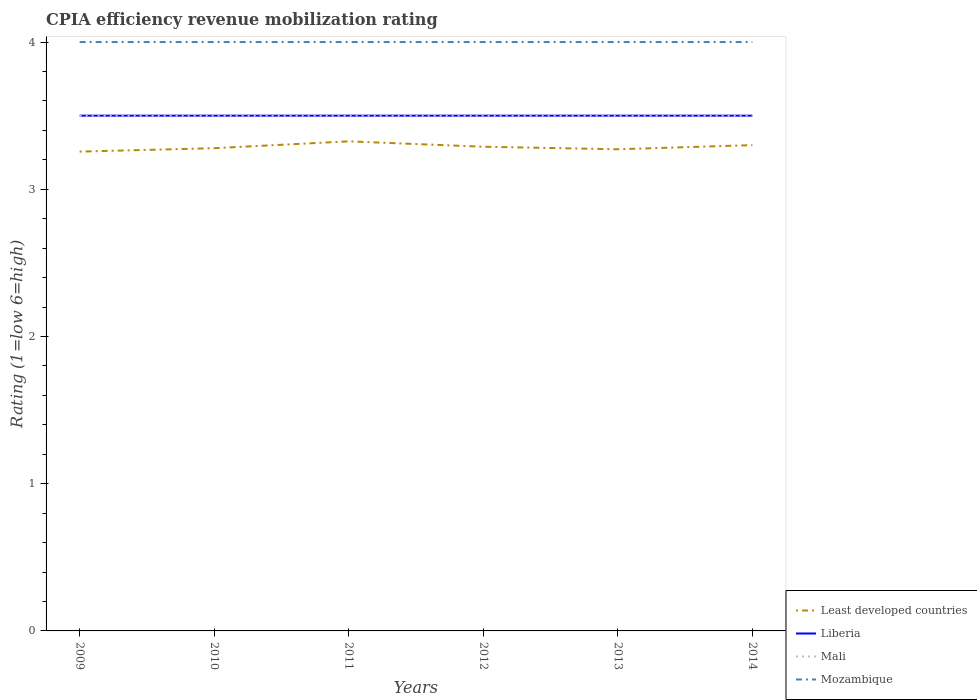In which year was the CPIA rating in Liberia maximum?
Make the answer very short. 2009. What is the total CPIA rating in Least developed countries in the graph?
Provide a succinct answer. -0.02. What is the difference between the highest and the lowest CPIA rating in Liberia?
Your answer should be very brief. 0. How many lines are there?
Provide a succinct answer. 4. Does the graph contain grids?
Provide a succinct answer. No. How many legend labels are there?
Provide a succinct answer. 4. What is the title of the graph?
Provide a short and direct response. CPIA efficiency revenue mobilization rating. Does "Denmark" appear as one of the legend labels in the graph?
Your answer should be very brief. No. What is the label or title of the X-axis?
Make the answer very short. Years. What is the Rating (1=low 6=high) of Least developed countries in 2009?
Provide a short and direct response. 3.26. What is the Rating (1=low 6=high) of Liberia in 2009?
Offer a terse response. 3.5. What is the Rating (1=low 6=high) of Mali in 2009?
Your answer should be compact. 3.5. What is the Rating (1=low 6=high) of Least developed countries in 2010?
Ensure brevity in your answer.  3.28. What is the Rating (1=low 6=high) in Liberia in 2010?
Provide a succinct answer. 3.5. What is the Rating (1=low 6=high) of Mozambique in 2010?
Your answer should be compact. 4. What is the Rating (1=low 6=high) of Least developed countries in 2011?
Make the answer very short. 3.33. What is the Rating (1=low 6=high) of Mali in 2011?
Make the answer very short. 3.5. What is the Rating (1=low 6=high) in Mozambique in 2011?
Offer a terse response. 4. What is the Rating (1=low 6=high) of Least developed countries in 2012?
Give a very brief answer. 3.29. What is the Rating (1=low 6=high) in Liberia in 2012?
Keep it short and to the point. 3.5. What is the Rating (1=low 6=high) of Least developed countries in 2013?
Your answer should be compact. 3.27. What is the Rating (1=low 6=high) in Liberia in 2013?
Keep it short and to the point. 3.5. What is the Rating (1=low 6=high) of Mali in 2013?
Make the answer very short. 3.5. What is the Rating (1=low 6=high) of Liberia in 2014?
Offer a terse response. 3.5. Across all years, what is the maximum Rating (1=low 6=high) in Least developed countries?
Ensure brevity in your answer.  3.33. Across all years, what is the minimum Rating (1=low 6=high) in Least developed countries?
Give a very brief answer. 3.26. Across all years, what is the minimum Rating (1=low 6=high) in Liberia?
Offer a very short reply. 3.5. Across all years, what is the minimum Rating (1=low 6=high) of Mozambique?
Provide a succinct answer. 4. What is the total Rating (1=low 6=high) of Least developed countries in the graph?
Offer a very short reply. 19.72. What is the total Rating (1=low 6=high) of Liberia in the graph?
Your answer should be compact. 21. What is the total Rating (1=low 6=high) of Mali in the graph?
Provide a short and direct response. 21. What is the difference between the Rating (1=low 6=high) of Least developed countries in 2009 and that in 2010?
Provide a succinct answer. -0.02. What is the difference between the Rating (1=low 6=high) in Mozambique in 2009 and that in 2010?
Ensure brevity in your answer.  0. What is the difference between the Rating (1=low 6=high) of Least developed countries in 2009 and that in 2011?
Ensure brevity in your answer.  -0.07. What is the difference between the Rating (1=low 6=high) of Least developed countries in 2009 and that in 2012?
Give a very brief answer. -0.03. What is the difference between the Rating (1=low 6=high) of Liberia in 2009 and that in 2012?
Ensure brevity in your answer.  0. What is the difference between the Rating (1=low 6=high) of Mozambique in 2009 and that in 2012?
Your answer should be very brief. 0. What is the difference between the Rating (1=low 6=high) in Least developed countries in 2009 and that in 2013?
Your answer should be compact. -0.02. What is the difference between the Rating (1=low 6=high) in Least developed countries in 2009 and that in 2014?
Make the answer very short. -0.04. What is the difference between the Rating (1=low 6=high) of Mali in 2009 and that in 2014?
Make the answer very short. 0. What is the difference between the Rating (1=low 6=high) of Mozambique in 2009 and that in 2014?
Give a very brief answer. 0. What is the difference between the Rating (1=low 6=high) of Least developed countries in 2010 and that in 2011?
Your answer should be very brief. -0.05. What is the difference between the Rating (1=low 6=high) of Liberia in 2010 and that in 2011?
Make the answer very short. 0. What is the difference between the Rating (1=low 6=high) in Least developed countries in 2010 and that in 2012?
Give a very brief answer. -0.01. What is the difference between the Rating (1=low 6=high) in Mozambique in 2010 and that in 2012?
Provide a succinct answer. 0. What is the difference between the Rating (1=low 6=high) in Least developed countries in 2010 and that in 2013?
Your response must be concise. 0.01. What is the difference between the Rating (1=low 6=high) of Liberia in 2010 and that in 2013?
Make the answer very short. 0. What is the difference between the Rating (1=low 6=high) in Mali in 2010 and that in 2013?
Keep it short and to the point. 0. What is the difference between the Rating (1=low 6=high) of Least developed countries in 2010 and that in 2014?
Offer a terse response. -0.02. What is the difference between the Rating (1=low 6=high) of Liberia in 2010 and that in 2014?
Your response must be concise. 0. What is the difference between the Rating (1=low 6=high) in Least developed countries in 2011 and that in 2012?
Provide a succinct answer. 0.04. What is the difference between the Rating (1=low 6=high) of Liberia in 2011 and that in 2012?
Make the answer very short. 0. What is the difference between the Rating (1=low 6=high) of Mali in 2011 and that in 2012?
Provide a short and direct response. 0. What is the difference between the Rating (1=low 6=high) in Least developed countries in 2011 and that in 2013?
Keep it short and to the point. 0.05. What is the difference between the Rating (1=low 6=high) in Mali in 2011 and that in 2013?
Your response must be concise. 0. What is the difference between the Rating (1=low 6=high) of Least developed countries in 2011 and that in 2014?
Provide a succinct answer. 0.03. What is the difference between the Rating (1=low 6=high) of Liberia in 2011 and that in 2014?
Ensure brevity in your answer.  0. What is the difference between the Rating (1=low 6=high) in Mozambique in 2011 and that in 2014?
Keep it short and to the point. 0. What is the difference between the Rating (1=low 6=high) of Least developed countries in 2012 and that in 2013?
Your response must be concise. 0.02. What is the difference between the Rating (1=low 6=high) of Liberia in 2012 and that in 2013?
Your answer should be compact. 0. What is the difference between the Rating (1=low 6=high) of Mali in 2012 and that in 2013?
Ensure brevity in your answer.  0. What is the difference between the Rating (1=low 6=high) of Least developed countries in 2012 and that in 2014?
Your answer should be compact. -0.01. What is the difference between the Rating (1=low 6=high) of Liberia in 2012 and that in 2014?
Your response must be concise. 0. What is the difference between the Rating (1=low 6=high) in Mali in 2012 and that in 2014?
Offer a terse response. 0. What is the difference between the Rating (1=low 6=high) in Mozambique in 2012 and that in 2014?
Offer a terse response. 0. What is the difference between the Rating (1=low 6=high) in Least developed countries in 2013 and that in 2014?
Your response must be concise. -0.03. What is the difference between the Rating (1=low 6=high) of Mali in 2013 and that in 2014?
Your answer should be very brief. 0. What is the difference between the Rating (1=low 6=high) of Least developed countries in 2009 and the Rating (1=low 6=high) of Liberia in 2010?
Offer a very short reply. -0.24. What is the difference between the Rating (1=low 6=high) of Least developed countries in 2009 and the Rating (1=low 6=high) of Mali in 2010?
Offer a terse response. -0.24. What is the difference between the Rating (1=low 6=high) of Least developed countries in 2009 and the Rating (1=low 6=high) of Mozambique in 2010?
Offer a terse response. -0.74. What is the difference between the Rating (1=low 6=high) in Least developed countries in 2009 and the Rating (1=low 6=high) in Liberia in 2011?
Give a very brief answer. -0.24. What is the difference between the Rating (1=low 6=high) of Least developed countries in 2009 and the Rating (1=low 6=high) of Mali in 2011?
Keep it short and to the point. -0.24. What is the difference between the Rating (1=low 6=high) in Least developed countries in 2009 and the Rating (1=low 6=high) in Mozambique in 2011?
Provide a succinct answer. -0.74. What is the difference between the Rating (1=low 6=high) in Liberia in 2009 and the Rating (1=low 6=high) in Mali in 2011?
Provide a succinct answer. 0. What is the difference between the Rating (1=low 6=high) of Liberia in 2009 and the Rating (1=low 6=high) of Mozambique in 2011?
Make the answer very short. -0.5. What is the difference between the Rating (1=low 6=high) of Least developed countries in 2009 and the Rating (1=low 6=high) of Liberia in 2012?
Your response must be concise. -0.24. What is the difference between the Rating (1=low 6=high) of Least developed countries in 2009 and the Rating (1=low 6=high) of Mali in 2012?
Keep it short and to the point. -0.24. What is the difference between the Rating (1=low 6=high) in Least developed countries in 2009 and the Rating (1=low 6=high) in Mozambique in 2012?
Give a very brief answer. -0.74. What is the difference between the Rating (1=low 6=high) in Liberia in 2009 and the Rating (1=low 6=high) in Mali in 2012?
Your response must be concise. 0. What is the difference between the Rating (1=low 6=high) in Mali in 2009 and the Rating (1=low 6=high) in Mozambique in 2012?
Your answer should be compact. -0.5. What is the difference between the Rating (1=low 6=high) of Least developed countries in 2009 and the Rating (1=low 6=high) of Liberia in 2013?
Ensure brevity in your answer.  -0.24. What is the difference between the Rating (1=low 6=high) of Least developed countries in 2009 and the Rating (1=low 6=high) of Mali in 2013?
Offer a terse response. -0.24. What is the difference between the Rating (1=low 6=high) in Least developed countries in 2009 and the Rating (1=low 6=high) in Mozambique in 2013?
Make the answer very short. -0.74. What is the difference between the Rating (1=low 6=high) in Liberia in 2009 and the Rating (1=low 6=high) in Mozambique in 2013?
Provide a succinct answer. -0.5. What is the difference between the Rating (1=low 6=high) in Least developed countries in 2009 and the Rating (1=low 6=high) in Liberia in 2014?
Offer a very short reply. -0.24. What is the difference between the Rating (1=low 6=high) in Least developed countries in 2009 and the Rating (1=low 6=high) in Mali in 2014?
Ensure brevity in your answer.  -0.24. What is the difference between the Rating (1=low 6=high) in Least developed countries in 2009 and the Rating (1=low 6=high) in Mozambique in 2014?
Ensure brevity in your answer.  -0.74. What is the difference between the Rating (1=low 6=high) of Liberia in 2009 and the Rating (1=low 6=high) of Mozambique in 2014?
Provide a succinct answer. -0.5. What is the difference between the Rating (1=low 6=high) of Least developed countries in 2010 and the Rating (1=low 6=high) of Liberia in 2011?
Your answer should be very brief. -0.22. What is the difference between the Rating (1=low 6=high) of Least developed countries in 2010 and the Rating (1=low 6=high) of Mali in 2011?
Keep it short and to the point. -0.22. What is the difference between the Rating (1=low 6=high) of Least developed countries in 2010 and the Rating (1=low 6=high) of Mozambique in 2011?
Provide a succinct answer. -0.72. What is the difference between the Rating (1=low 6=high) in Liberia in 2010 and the Rating (1=low 6=high) in Mali in 2011?
Provide a short and direct response. 0. What is the difference between the Rating (1=low 6=high) in Least developed countries in 2010 and the Rating (1=low 6=high) in Liberia in 2012?
Ensure brevity in your answer.  -0.22. What is the difference between the Rating (1=low 6=high) of Least developed countries in 2010 and the Rating (1=low 6=high) of Mali in 2012?
Make the answer very short. -0.22. What is the difference between the Rating (1=low 6=high) in Least developed countries in 2010 and the Rating (1=low 6=high) in Mozambique in 2012?
Offer a very short reply. -0.72. What is the difference between the Rating (1=low 6=high) of Liberia in 2010 and the Rating (1=low 6=high) of Mali in 2012?
Your response must be concise. 0. What is the difference between the Rating (1=low 6=high) in Liberia in 2010 and the Rating (1=low 6=high) in Mozambique in 2012?
Make the answer very short. -0.5. What is the difference between the Rating (1=low 6=high) in Least developed countries in 2010 and the Rating (1=low 6=high) in Liberia in 2013?
Your response must be concise. -0.22. What is the difference between the Rating (1=low 6=high) of Least developed countries in 2010 and the Rating (1=low 6=high) of Mali in 2013?
Keep it short and to the point. -0.22. What is the difference between the Rating (1=low 6=high) of Least developed countries in 2010 and the Rating (1=low 6=high) of Mozambique in 2013?
Offer a very short reply. -0.72. What is the difference between the Rating (1=low 6=high) of Liberia in 2010 and the Rating (1=low 6=high) of Mozambique in 2013?
Your response must be concise. -0.5. What is the difference between the Rating (1=low 6=high) in Mali in 2010 and the Rating (1=low 6=high) in Mozambique in 2013?
Provide a succinct answer. -0.5. What is the difference between the Rating (1=low 6=high) of Least developed countries in 2010 and the Rating (1=low 6=high) of Liberia in 2014?
Provide a succinct answer. -0.22. What is the difference between the Rating (1=low 6=high) in Least developed countries in 2010 and the Rating (1=low 6=high) in Mali in 2014?
Offer a terse response. -0.22. What is the difference between the Rating (1=low 6=high) of Least developed countries in 2010 and the Rating (1=low 6=high) of Mozambique in 2014?
Offer a terse response. -0.72. What is the difference between the Rating (1=low 6=high) of Liberia in 2010 and the Rating (1=low 6=high) of Mali in 2014?
Give a very brief answer. 0. What is the difference between the Rating (1=low 6=high) of Mali in 2010 and the Rating (1=low 6=high) of Mozambique in 2014?
Provide a succinct answer. -0.5. What is the difference between the Rating (1=low 6=high) of Least developed countries in 2011 and the Rating (1=low 6=high) of Liberia in 2012?
Your answer should be compact. -0.17. What is the difference between the Rating (1=low 6=high) in Least developed countries in 2011 and the Rating (1=low 6=high) in Mali in 2012?
Provide a succinct answer. -0.17. What is the difference between the Rating (1=low 6=high) of Least developed countries in 2011 and the Rating (1=low 6=high) of Mozambique in 2012?
Make the answer very short. -0.67. What is the difference between the Rating (1=low 6=high) of Liberia in 2011 and the Rating (1=low 6=high) of Mali in 2012?
Ensure brevity in your answer.  0. What is the difference between the Rating (1=low 6=high) in Least developed countries in 2011 and the Rating (1=low 6=high) in Liberia in 2013?
Your response must be concise. -0.17. What is the difference between the Rating (1=low 6=high) of Least developed countries in 2011 and the Rating (1=low 6=high) of Mali in 2013?
Provide a succinct answer. -0.17. What is the difference between the Rating (1=low 6=high) in Least developed countries in 2011 and the Rating (1=low 6=high) in Mozambique in 2013?
Ensure brevity in your answer.  -0.67. What is the difference between the Rating (1=low 6=high) in Liberia in 2011 and the Rating (1=low 6=high) in Mozambique in 2013?
Provide a succinct answer. -0.5. What is the difference between the Rating (1=low 6=high) in Mali in 2011 and the Rating (1=low 6=high) in Mozambique in 2013?
Provide a succinct answer. -0.5. What is the difference between the Rating (1=low 6=high) in Least developed countries in 2011 and the Rating (1=low 6=high) in Liberia in 2014?
Provide a succinct answer. -0.17. What is the difference between the Rating (1=low 6=high) of Least developed countries in 2011 and the Rating (1=low 6=high) of Mali in 2014?
Provide a short and direct response. -0.17. What is the difference between the Rating (1=low 6=high) of Least developed countries in 2011 and the Rating (1=low 6=high) of Mozambique in 2014?
Give a very brief answer. -0.67. What is the difference between the Rating (1=low 6=high) of Least developed countries in 2012 and the Rating (1=low 6=high) of Liberia in 2013?
Give a very brief answer. -0.21. What is the difference between the Rating (1=low 6=high) of Least developed countries in 2012 and the Rating (1=low 6=high) of Mali in 2013?
Provide a succinct answer. -0.21. What is the difference between the Rating (1=low 6=high) of Least developed countries in 2012 and the Rating (1=low 6=high) of Mozambique in 2013?
Provide a short and direct response. -0.71. What is the difference between the Rating (1=low 6=high) in Liberia in 2012 and the Rating (1=low 6=high) in Mozambique in 2013?
Your response must be concise. -0.5. What is the difference between the Rating (1=low 6=high) of Mali in 2012 and the Rating (1=low 6=high) of Mozambique in 2013?
Give a very brief answer. -0.5. What is the difference between the Rating (1=low 6=high) in Least developed countries in 2012 and the Rating (1=low 6=high) in Liberia in 2014?
Your answer should be compact. -0.21. What is the difference between the Rating (1=low 6=high) of Least developed countries in 2012 and the Rating (1=low 6=high) of Mali in 2014?
Ensure brevity in your answer.  -0.21. What is the difference between the Rating (1=low 6=high) in Least developed countries in 2012 and the Rating (1=low 6=high) in Mozambique in 2014?
Your answer should be very brief. -0.71. What is the difference between the Rating (1=low 6=high) in Liberia in 2012 and the Rating (1=low 6=high) in Mali in 2014?
Provide a succinct answer. 0. What is the difference between the Rating (1=low 6=high) in Mali in 2012 and the Rating (1=low 6=high) in Mozambique in 2014?
Keep it short and to the point. -0.5. What is the difference between the Rating (1=low 6=high) of Least developed countries in 2013 and the Rating (1=low 6=high) of Liberia in 2014?
Provide a succinct answer. -0.23. What is the difference between the Rating (1=low 6=high) of Least developed countries in 2013 and the Rating (1=low 6=high) of Mali in 2014?
Offer a very short reply. -0.23. What is the difference between the Rating (1=low 6=high) in Least developed countries in 2013 and the Rating (1=low 6=high) in Mozambique in 2014?
Give a very brief answer. -0.73. What is the average Rating (1=low 6=high) in Least developed countries per year?
Provide a succinct answer. 3.29. What is the average Rating (1=low 6=high) in Mali per year?
Your response must be concise. 3.5. What is the average Rating (1=low 6=high) of Mozambique per year?
Make the answer very short. 4. In the year 2009, what is the difference between the Rating (1=low 6=high) of Least developed countries and Rating (1=low 6=high) of Liberia?
Keep it short and to the point. -0.24. In the year 2009, what is the difference between the Rating (1=low 6=high) in Least developed countries and Rating (1=low 6=high) in Mali?
Offer a very short reply. -0.24. In the year 2009, what is the difference between the Rating (1=low 6=high) in Least developed countries and Rating (1=low 6=high) in Mozambique?
Keep it short and to the point. -0.74. In the year 2009, what is the difference between the Rating (1=low 6=high) of Liberia and Rating (1=low 6=high) of Mozambique?
Ensure brevity in your answer.  -0.5. In the year 2010, what is the difference between the Rating (1=low 6=high) in Least developed countries and Rating (1=low 6=high) in Liberia?
Ensure brevity in your answer.  -0.22. In the year 2010, what is the difference between the Rating (1=low 6=high) of Least developed countries and Rating (1=low 6=high) of Mali?
Your answer should be very brief. -0.22. In the year 2010, what is the difference between the Rating (1=low 6=high) of Least developed countries and Rating (1=low 6=high) of Mozambique?
Your response must be concise. -0.72. In the year 2010, what is the difference between the Rating (1=low 6=high) of Liberia and Rating (1=low 6=high) of Mali?
Provide a succinct answer. 0. In the year 2010, what is the difference between the Rating (1=low 6=high) of Mali and Rating (1=low 6=high) of Mozambique?
Offer a very short reply. -0.5. In the year 2011, what is the difference between the Rating (1=low 6=high) of Least developed countries and Rating (1=low 6=high) of Liberia?
Your response must be concise. -0.17. In the year 2011, what is the difference between the Rating (1=low 6=high) in Least developed countries and Rating (1=low 6=high) in Mali?
Your response must be concise. -0.17. In the year 2011, what is the difference between the Rating (1=low 6=high) of Least developed countries and Rating (1=low 6=high) of Mozambique?
Offer a very short reply. -0.67. In the year 2011, what is the difference between the Rating (1=low 6=high) in Mali and Rating (1=low 6=high) in Mozambique?
Give a very brief answer. -0.5. In the year 2012, what is the difference between the Rating (1=low 6=high) of Least developed countries and Rating (1=low 6=high) of Liberia?
Provide a succinct answer. -0.21. In the year 2012, what is the difference between the Rating (1=low 6=high) in Least developed countries and Rating (1=low 6=high) in Mali?
Offer a very short reply. -0.21. In the year 2012, what is the difference between the Rating (1=low 6=high) in Least developed countries and Rating (1=low 6=high) in Mozambique?
Keep it short and to the point. -0.71. In the year 2012, what is the difference between the Rating (1=low 6=high) in Liberia and Rating (1=low 6=high) in Mozambique?
Provide a succinct answer. -0.5. In the year 2012, what is the difference between the Rating (1=low 6=high) in Mali and Rating (1=low 6=high) in Mozambique?
Ensure brevity in your answer.  -0.5. In the year 2013, what is the difference between the Rating (1=low 6=high) of Least developed countries and Rating (1=low 6=high) of Liberia?
Your answer should be compact. -0.23. In the year 2013, what is the difference between the Rating (1=low 6=high) in Least developed countries and Rating (1=low 6=high) in Mali?
Ensure brevity in your answer.  -0.23. In the year 2013, what is the difference between the Rating (1=low 6=high) of Least developed countries and Rating (1=low 6=high) of Mozambique?
Give a very brief answer. -0.73. In the year 2013, what is the difference between the Rating (1=low 6=high) of Liberia and Rating (1=low 6=high) of Mali?
Make the answer very short. 0. In the year 2014, what is the difference between the Rating (1=low 6=high) of Least developed countries and Rating (1=low 6=high) of Mali?
Make the answer very short. -0.2. In the year 2014, what is the difference between the Rating (1=low 6=high) in Liberia and Rating (1=low 6=high) in Mali?
Offer a terse response. 0. In the year 2014, what is the difference between the Rating (1=low 6=high) in Liberia and Rating (1=low 6=high) in Mozambique?
Provide a succinct answer. -0.5. In the year 2014, what is the difference between the Rating (1=low 6=high) of Mali and Rating (1=low 6=high) of Mozambique?
Provide a succinct answer. -0.5. What is the ratio of the Rating (1=low 6=high) of Least developed countries in 2009 to that in 2010?
Provide a succinct answer. 0.99. What is the ratio of the Rating (1=low 6=high) in Liberia in 2009 to that in 2010?
Provide a succinct answer. 1. What is the ratio of the Rating (1=low 6=high) of Mali in 2009 to that in 2010?
Your response must be concise. 1. What is the ratio of the Rating (1=low 6=high) of Liberia in 2009 to that in 2011?
Ensure brevity in your answer.  1. What is the ratio of the Rating (1=low 6=high) in Least developed countries in 2009 to that in 2012?
Give a very brief answer. 0.99. What is the ratio of the Rating (1=low 6=high) in Mozambique in 2009 to that in 2013?
Keep it short and to the point. 1. What is the ratio of the Rating (1=low 6=high) of Least developed countries in 2009 to that in 2014?
Your answer should be very brief. 0.99. What is the ratio of the Rating (1=low 6=high) of Mali in 2009 to that in 2014?
Your answer should be very brief. 1. What is the ratio of the Rating (1=low 6=high) of Mozambique in 2009 to that in 2014?
Offer a very short reply. 1. What is the ratio of the Rating (1=low 6=high) in Least developed countries in 2010 to that in 2011?
Your answer should be very brief. 0.99. What is the ratio of the Rating (1=low 6=high) in Liberia in 2010 to that in 2011?
Give a very brief answer. 1. What is the ratio of the Rating (1=low 6=high) in Mali in 2010 to that in 2011?
Your response must be concise. 1. What is the ratio of the Rating (1=low 6=high) in Mozambique in 2010 to that in 2011?
Your answer should be very brief. 1. What is the ratio of the Rating (1=low 6=high) in Least developed countries in 2010 to that in 2012?
Ensure brevity in your answer.  1. What is the ratio of the Rating (1=low 6=high) in Liberia in 2010 to that in 2012?
Offer a very short reply. 1. What is the ratio of the Rating (1=low 6=high) of Mozambique in 2010 to that in 2012?
Your response must be concise. 1. What is the ratio of the Rating (1=low 6=high) of Least developed countries in 2010 to that in 2013?
Your response must be concise. 1. What is the ratio of the Rating (1=low 6=high) in Liberia in 2010 to that in 2013?
Offer a terse response. 1. What is the ratio of the Rating (1=low 6=high) in Mali in 2010 to that in 2013?
Offer a terse response. 1. What is the ratio of the Rating (1=low 6=high) in Mozambique in 2010 to that in 2013?
Your answer should be very brief. 1. What is the ratio of the Rating (1=low 6=high) of Least developed countries in 2010 to that in 2014?
Offer a very short reply. 0.99. What is the ratio of the Rating (1=low 6=high) in Liberia in 2010 to that in 2014?
Ensure brevity in your answer.  1. What is the ratio of the Rating (1=low 6=high) of Least developed countries in 2011 to that in 2012?
Provide a succinct answer. 1.01. What is the ratio of the Rating (1=low 6=high) of Liberia in 2011 to that in 2012?
Ensure brevity in your answer.  1. What is the ratio of the Rating (1=low 6=high) of Mali in 2011 to that in 2012?
Offer a very short reply. 1. What is the ratio of the Rating (1=low 6=high) of Least developed countries in 2011 to that in 2013?
Provide a short and direct response. 1.02. What is the ratio of the Rating (1=low 6=high) in Mali in 2011 to that in 2013?
Give a very brief answer. 1. What is the ratio of the Rating (1=low 6=high) in Mozambique in 2011 to that in 2013?
Your answer should be very brief. 1. What is the ratio of the Rating (1=low 6=high) of Least developed countries in 2011 to that in 2014?
Your response must be concise. 1.01. What is the ratio of the Rating (1=low 6=high) in Mozambique in 2011 to that in 2014?
Keep it short and to the point. 1. What is the ratio of the Rating (1=low 6=high) in Least developed countries in 2012 to that in 2014?
Your answer should be compact. 1. What is the ratio of the Rating (1=low 6=high) of Liberia in 2012 to that in 2014?
Ensure brevity in your answer.  1. What is the ratio of the Rating (1=low 6=high) in Mozambique in 2012 to that in 2014?
Make the answer very short. 1. What is the ratio of the Rating (1=low 6=high) of Mali in 2013 to that in 2014?
Your response must be concise. 1. What is the ratio of the Rating (1=low 6=high) in Mozambique in 2013 to that in 2014?
Provide a short and direct response. 1. What is the difference between the highest and the second highest Rating (1=low 6=high) in Least developed countries?
Provide a succinct answer. 0.03. What is the difference between the highest and the second highest Rating (1=low 6=high) in Mozambique?
Give a very brief answer. 0. What is the difference between the highest and the lowest Rating (1=low 6=high) of Least developed countries?
Offer a terse response. 0.07. What is the difference between the highest and the lowest Rating (1=low 6=high) in Mali?
Provide a succinct answer. 0. 